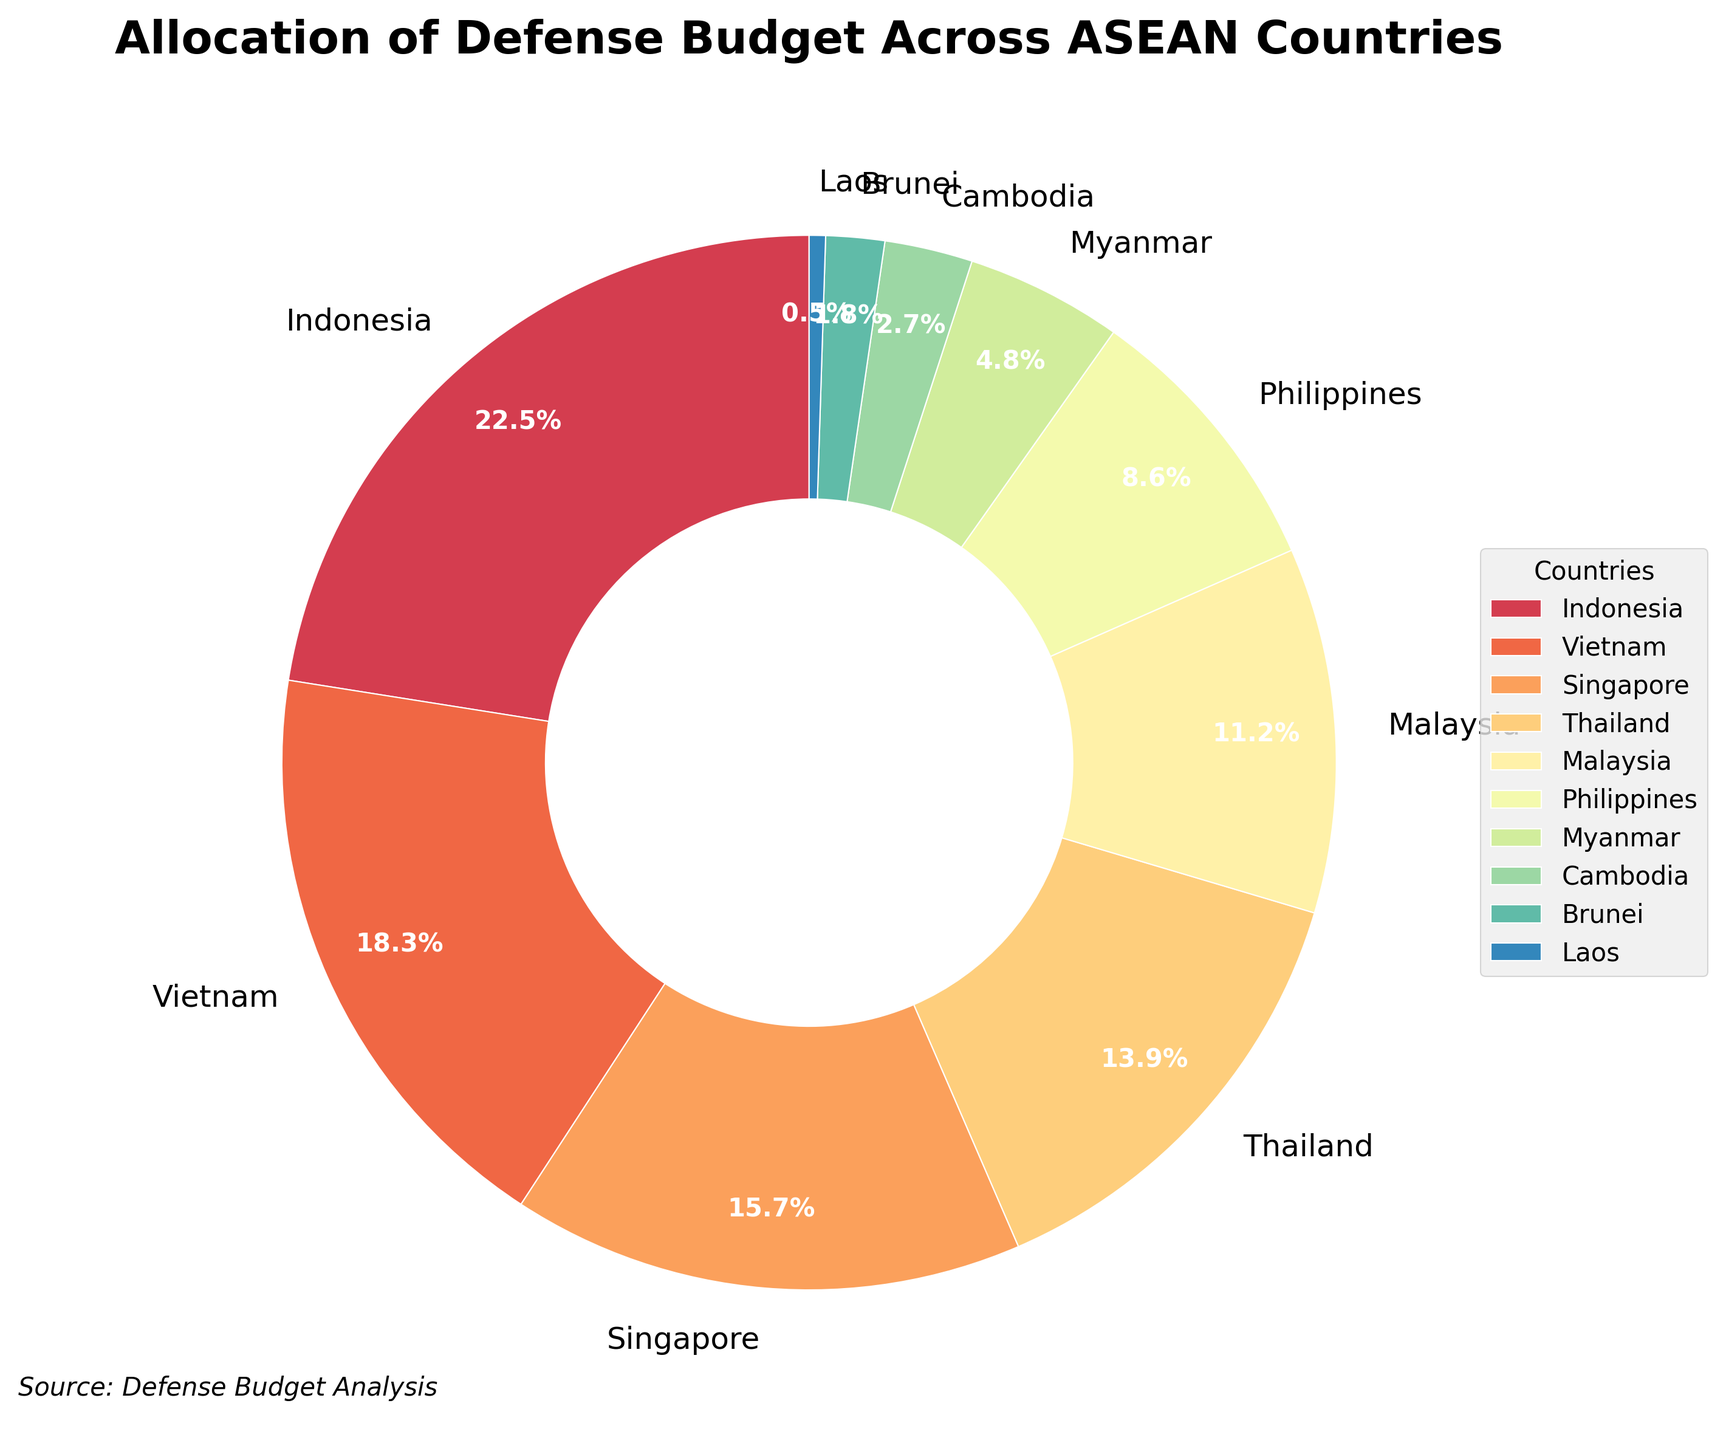What percentage of the defense budget is allocated to Indonesia? Look at the corresponding sector for Indonesia within the pie chart and read the percentage value labeled on it.
Answer: 22.5% Which two countries combined have a higher defense budget allocation than Indonesia? Sum the percentages of different countries and compare it with Indonesia's 22.5%. For example, Vietnam (18.3%) and Singapore (15.7%); 18.3 + 15.7 = 34.0, which is more than Indonesia's 22.5%.
Answer: Vietnam and Singapore Which country has the smallest allocation of the defense budget among the ASEAN countries? Look at the pie chart sectors and identify the smallest one by comparing all labels. Laos has 0.5%, which is the smallest.
Answer: Laos How much more defense budget allocation does Thailand have compared to Malaysia? Subtract Malaysia's percentage from Thailand's percentage: 13.9% - 11.2% = 2.7%.
Answer: 2.7% What are the top three countries in terms of defense budget allocation? Identify the largest sectors visually and confirm the corresponding countries and percentages. The top three are Indonesia (22.5%), Vietnam (18.3%), and Singapore (15.7%).
Answer: Indonesia, Vietnam, Singapore How does the defense budget allocation of the Philippines compare to Malaysia's? Compare the percentages of the Philippines (8.6%) with Malaysia (11.2%). The Philippines has less than Malaysia.
Answer: Less What is the total percentage of defense budget allocated to Myanmar, Cambodia, Brunei, and Laos? Add up the respective percentages: 4.8% + 2.7% + 1.8% + 0.5% = 9.8%.
Answer: 9.8% What is the color of the sector representing Thailand in the pie chart? Look at the pie chart and identify the color used for Thailand's sector.
Answer: (Actual color needs to be identified from the chart, let's assume) Light blue Which countries have a combined defense budget allocation of more than 50%? Sum the percentages of the top countries until the total exceeds 50%. Indonesia (22.5%) + Vietnam (18.3%) + Singapore (15.7%) = 56.5%.
Answer: Indonesia, Vietnam, Singapore What is the percentage difference in defense budget allocation between Vietnam and Brunei? Subtract Brunei's percentage from Vietnam's percentage: 18.3% - 1.8% = 16.5%.
Answer: 16.5% 